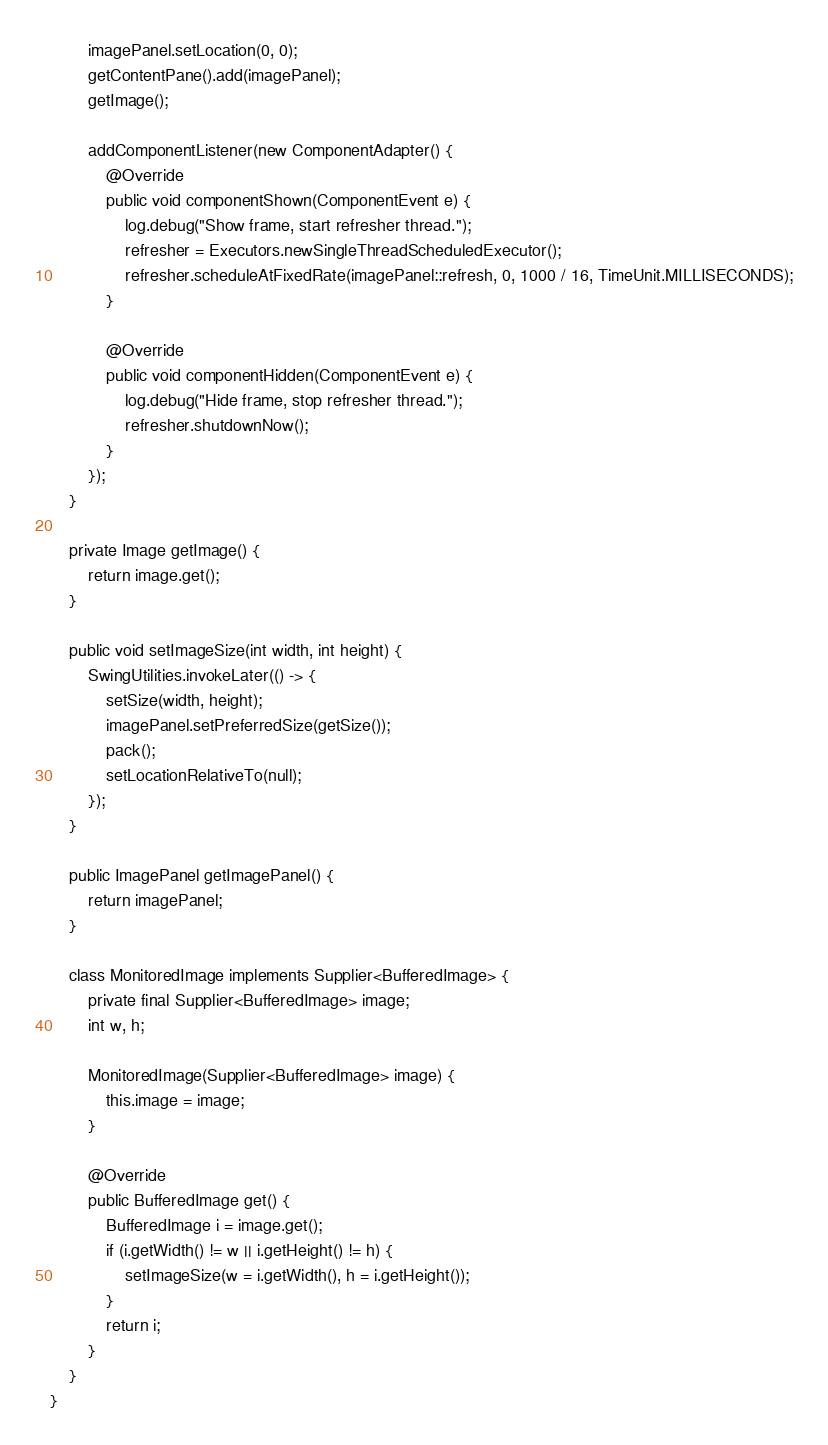Convert code to text. <code><loc_0><loc_0><loc_500><loc_500><_Java_>        imagePanel.setLocation(0, 0);
        getContentPane().add(imagePanel);
        getImage();

        addComponentListener(new ComponentAdapter() {
            @Override
            public void componentShown(ComponentEvent e) {
                log.debug("Show frame, start refresher thread.");
                refresher = Executors.newSingleThreadScheduledExecutor();
                refresher.scheduleAtFixedRate(imagePanel::refresh, 0, 1000 / 16, TimeUnit.MILLISECONDS);
            }

            @Override
            public void componentHidden(ComponentEvent e) {
                log.debug("Hide frame, stop refresher thread.");
                refresher.shutdownNow();
            }
        });
    }

    private Image getImage() {
        return image.get();
    }

    public void setImageSize(int width, int height) {
        SwingUtilities.invokeLater(() -> {
            setSize(width, height);
            imagePanel.setPreferredSize(getSize());
            pack();
            setLocationRelativeTo(null);
        });
    }

    public ImagePanel getImagePanel() {
        return imagePanel;
    }

    class MonitoredImage implements Supplier<BufferedImage> {
        private final Supplier<BufferedImage> image;
        int w, h;

        MonitoredImage(Supplier<BufferedImage> image) {
            this.image = image;
        }

        @Override
        public BufferedImage get() {
            BufferedImage i = image.get();
            if (i.getWidth() != w || i.getHeight() != h) {
                setImageSize(w = i.getWidth(), h = i.getHeight());
            }
            return i;
        }
    }
}
</code> 